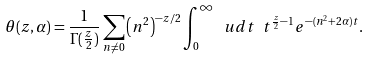Convert formula to latex. <formula><loc_0><loc_0><loc_500><loc_500>\theta ( z , \alpha ) = \frac { 1 } { \Gamma ( \frac { z } { 2 } ) } \sum _ { { n } \neq 0 } \left ( { n } ^ { 2 } \right ) ^ { - z / 2 } \int _ { 0 } ^ { \infty } \ u d t \ t ^ { \frac { z } { 2 } - 1 } e ^ { - ( { n } ^ { 2 } + 2 \alpha ) t } .</formula> 